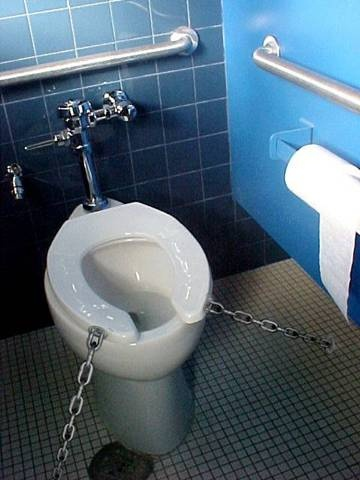Describe the objects in this image and their specific colors. I can see a toilet in lightblue, darkgray, gray, lightgray, and black tones in this image. 